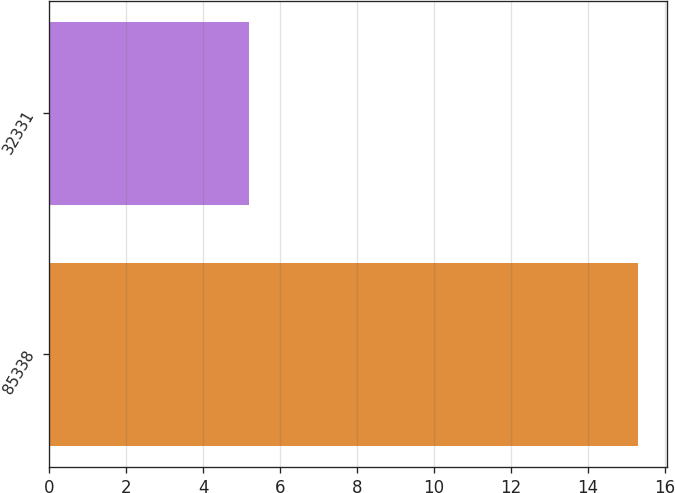<chart> <loc_0><loc_0><loc_500><loc_500><bar_chart><fcel>85338<fcel>32331<nl><fcel>15.3<fcel>5.2<nl></chart> 